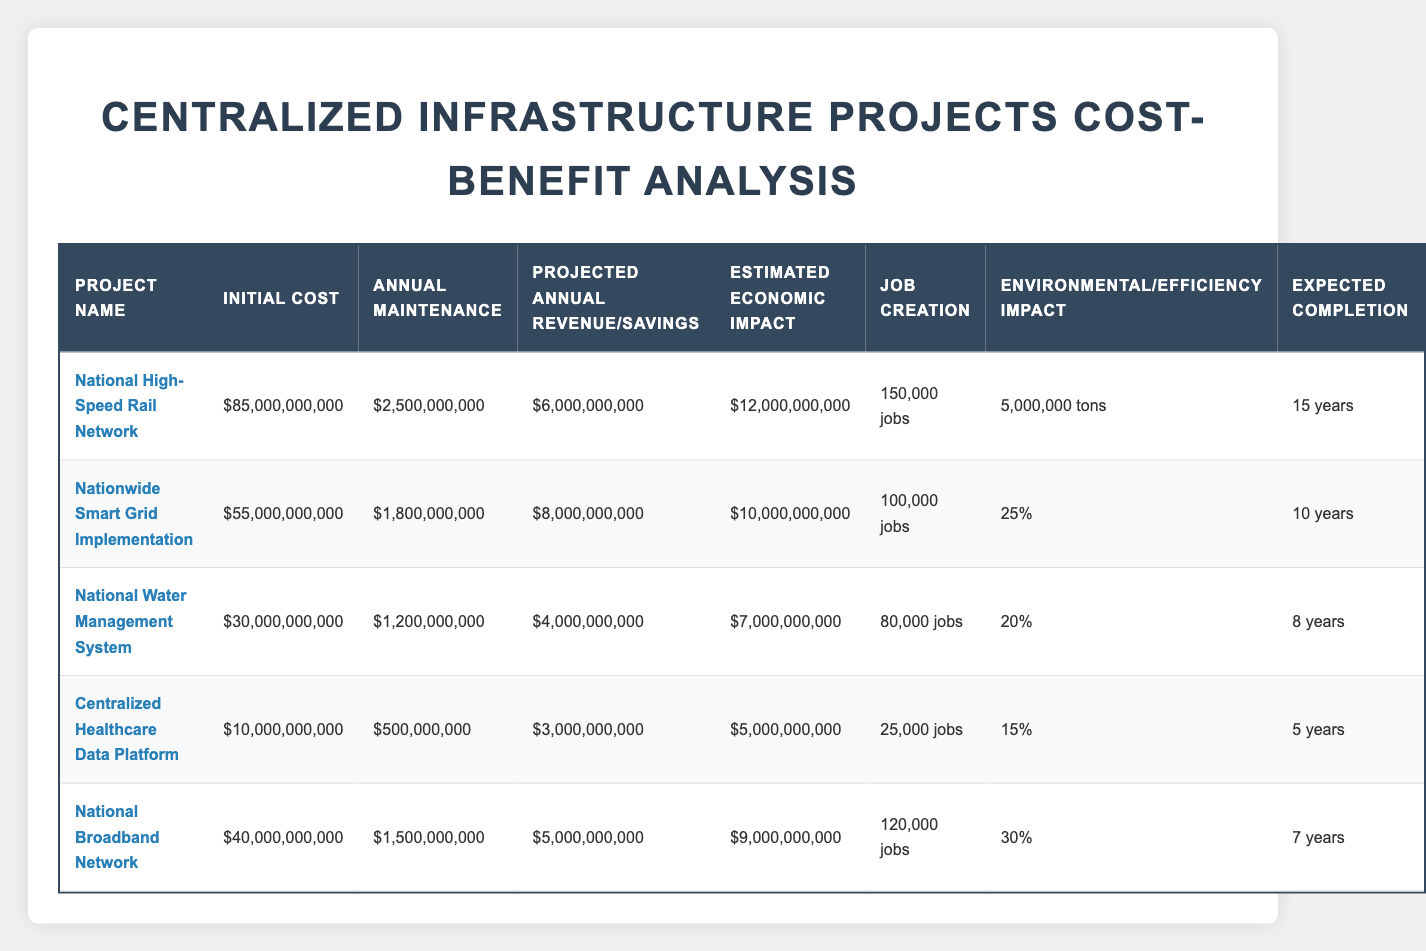What is the initial cost of the National High-Speed Rail Network? The initial cost for the National High-Speed Rail Network is clearly stated in the table as 85,000,000,000.
Answer: 85,000,000,000 How many jobs will the Nationwide Smart Grid Implementation create? The table indicates that the job creation for the Nationwide Smart Grid Implementation is 100,000.
Answer: 100,000 Which project has the highest estimated economic impact? By comparing the estimated economic impacts listed in the table, the National High-Speed Rail Network has the highest impact at 12,000,000,000.
Answer: National High-Speed Rail Network What is the total job creation for projects with completion years less than 10? The relevant projects are: Centralized Healthcare Data Platform (25,000 jobs) and National Broadband Network (120,000 jobs). Summing these gives 25,000 + 120,000 = 145,000.
Answer: 145,000 Does the Centralized Healthcare Data Platform have a projected annual savings? The table shows that the Centralized Healthcare Data Platform has projected annual savings of 3,000,000,000. Hence, the answer is yes.
Answer: Yes Which project has the lowest annual maintenance cost, and what is that amount? By reviewing the annual maintenance costs for each project, the Centralized Healthcare Data Platform has the lowest at 500,000,000.
Answer: Centralized Healthcare Data Platform, 500,000,000 What is the average projected annual revenue/savings of all listed projects? The projected annual revenues/savings are 6,000,000,000 (High-Speed Rail) + 8,000,000,000 (Smart Grid) + 4,000,000,000 (Water Management) + 3,000,000,000 (Healthcare Data) + 5,000,000,000 (Broadband) = 26,000,000,000. With 5 projects, the average is 26,000,000,000 / 5 = 5,200,000,000.
Answer: 5,200,000,000 Is the job creation of the National Water Management System greater than that of the Centralized Healthcare Data Platform? The table shows the National Water Management System has 80,000 jobs while the Centralized Healthcare Data Platform has 25,000 jobs; therefore, 80,000 is greater than 25,000.
Answer: Yes Which project has the highest carbon reduction per year, and how much is it? The National High-Speed Rail Network offers a carbon reduction of 5,000,000 tons per year, which is the highest among the listed projects.
Answer: National High-Speed Rail Network, 5,000,000 tons per year 